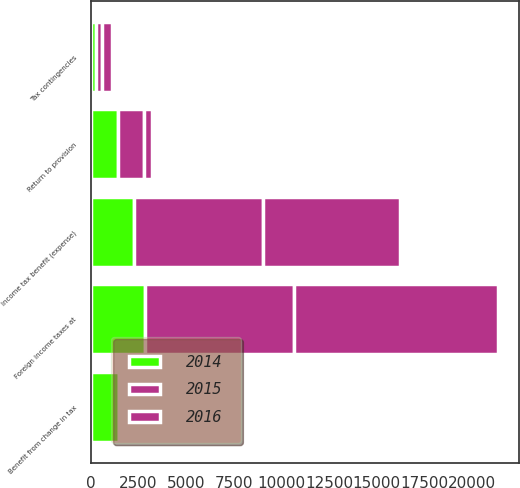Convert chart. <chart><loc_0><loc_0><loc_500><loc_500><stacked_bar_chart><ecel><fcel>Foreign income taxes at<fcel>Tax contingencies<fcel>Return to provision<fcel>Benefit from change in tax<fcel>Income tax benefit (expense)<nl><fcel>2016<fcel>10721<fcel>533<fcel>418<fcel>24<fcel>7218<nl><fcel>2015<fcel>7864<fcel>283<fcel>1370<fcel>5<fcel>6772<nl><fcel>2014<fcel>2813<fcel>275<fcel>1416<fcel>1462<fcel>2267<nl></chart> 